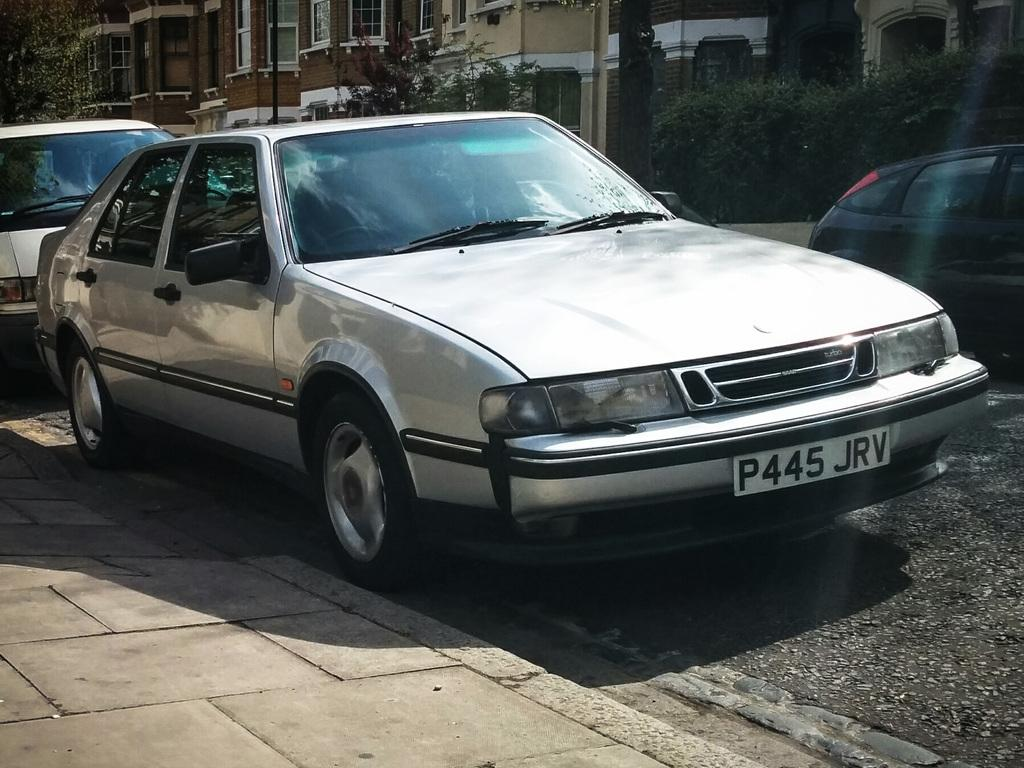What is the main feature of the image? There is a road in the image. What is happening on the road? There are vehicles on the road. What can be seen in the background of the image? There are trees and buildings in the background of the image. What type of pleasure can be seen being derived from the behavior of the trees in the image? There are no trees exhibiting behavior in the image, as trees are stationary objects. 